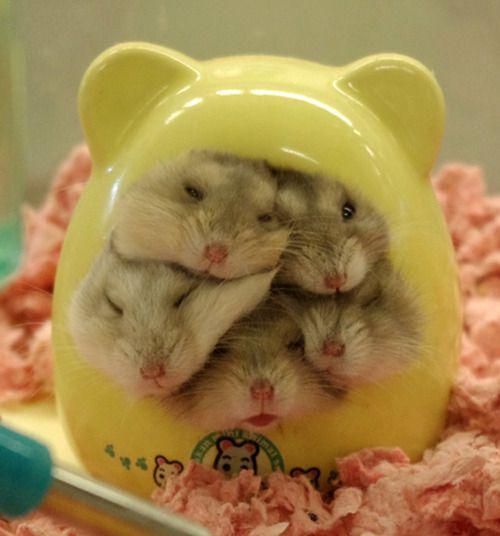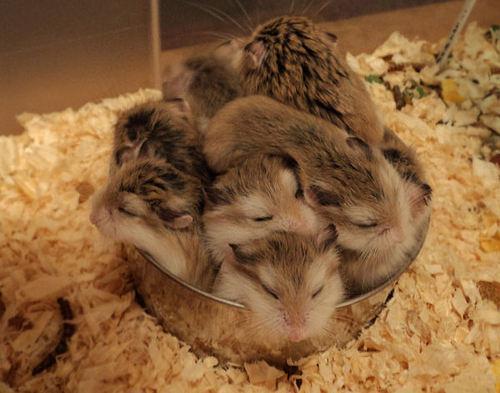The first image is the image on the left, the second image is the image on the right. Evaluate the accuracy of this statement regarding the images: "An image shows pet rodents inside a container with an opening at the front.". Is it true? Answer yes or no. Yes. The first image is the image on the left, the second image is the image on the right. Analyze the images presented: Is the assertion "There is human hand carrying a hamster." valid? Answer yes or no. No. 